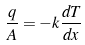<formula> <loc_0><loc_0><loc_500><loc_500>\frac { q } { A } = - k \frac { d T } { d x }</formula> 